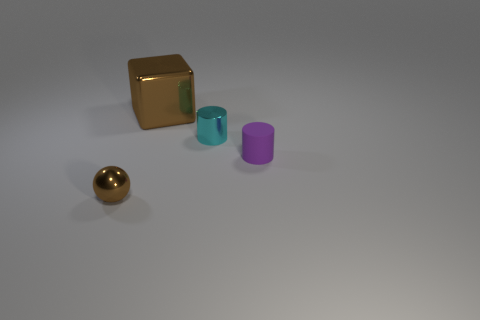Is there any other thing that has the same material as the purple cylinder?
Your answer should be compact. No. How many other objects are there of the same material as the small brown ball?
Your answer should be compact. 2. What is the size of the cylinder that is behind the tiny rubber thing?
Offer a very short reply. Small. What number of metallic things are both in front of the small matte cylinder and behind the small metallic sphere?
Your response must be concise. 0. What material is the brown object in front of the cylinder that is behind the purple thing?
Offer a very short reply. Metal. What material is the other tiny cyan object that is the same shape as the matte thing?
Offer a terse response. Metal. Are there any tiny brown metallic objects?
Make the answer very short. Yes. What shape is the brown thing that is the same material as the big brown cube?
Ensure brevity in your answer.  Sphere. There is a object that is in front of the matte cylinder; what material is it?
Offer a terse response. Metal. Do the tiny metal object that is left of the big block and the big metallic object have the same color?
Keep it short and to the point. Yes. 